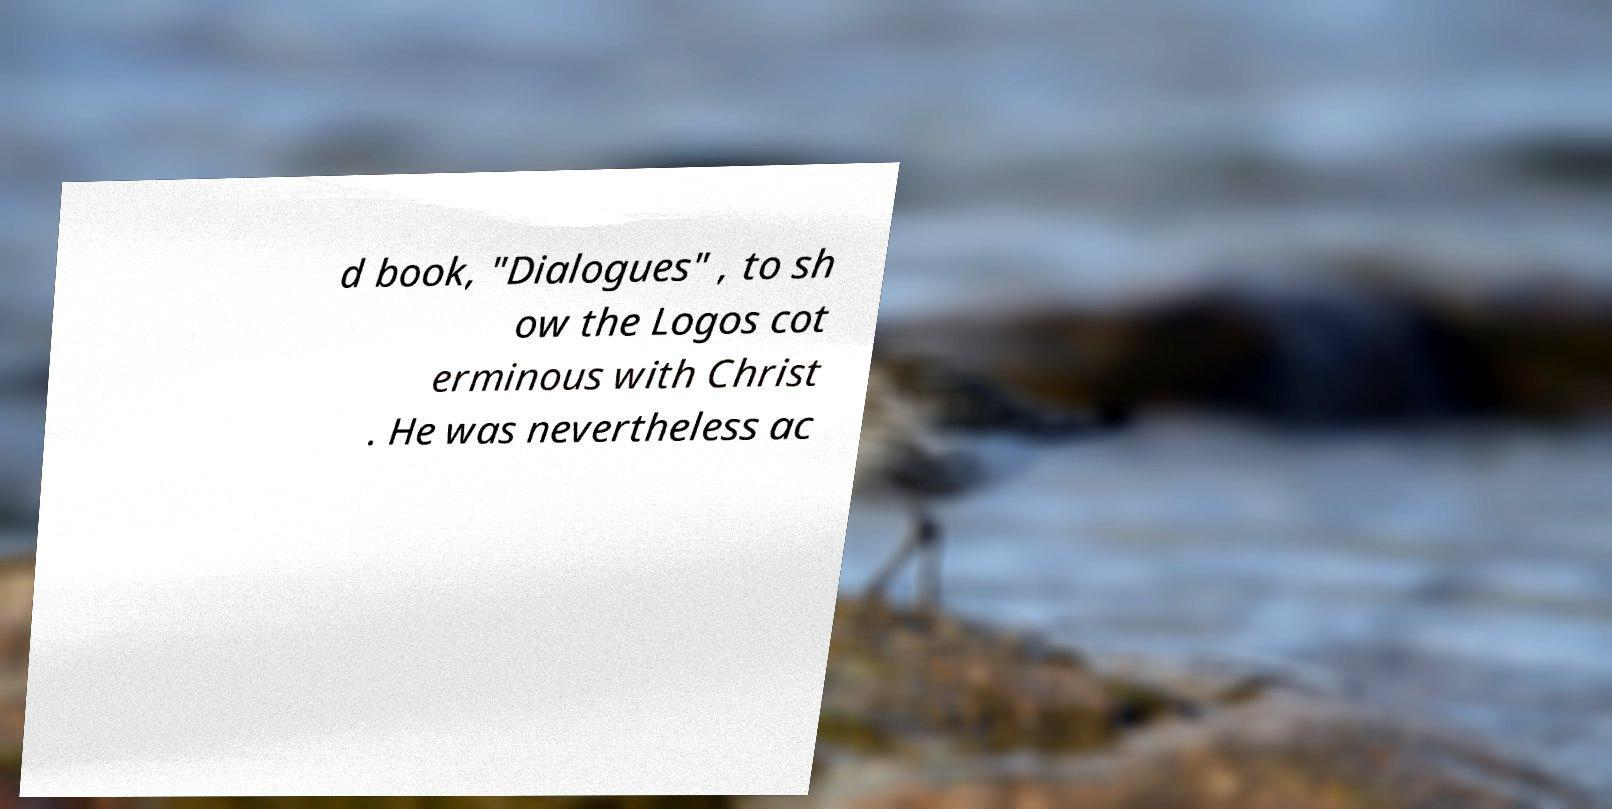I need the written content from this picture converted into text. Can you do that? d book, "Dialogues" , to sh ow the Logos cot erminous with Christ . He was nevertheless ac 